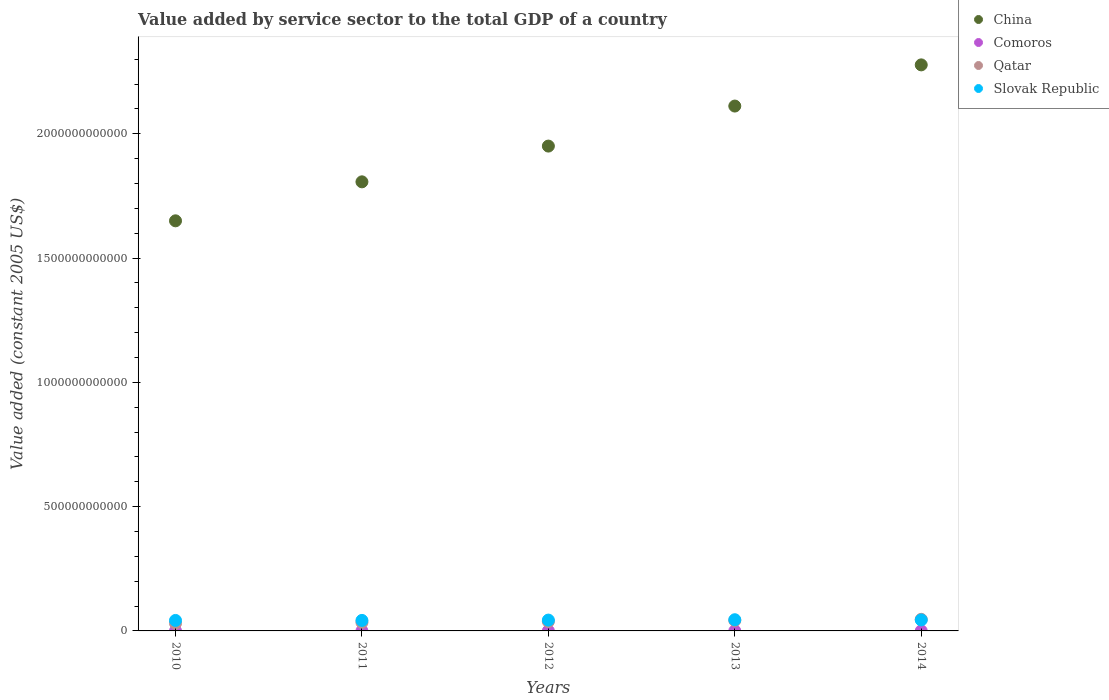What is the value added by service sector in Slovak Republic in 2014?
Offer a terse response. 4.41e+1. Across all years, what is the maximum value added by service sector in Qatar?
Provide a short and direct response. 4.66e+1. Across all years, what is the minimum value added by service sector in Slovak Republic?
Your answer should be very brief. 4.22e+1. In which year was the value added by service sector in Slovak Republic minimum?
Your answer should be compact. 2010. What is the total value added by service sector in Slovak Republic in the graph?
Your response must be concise. 2.17e+11. What is the difference between the value added by service sector in Slovak Republic in 2011 and that in 2014?
Make the answer very short. -1.86e+09. What is the difference between the value added by service sector in Qatar in 2014 and the value added by service sector in Comoros in 2010?
Your answer should be very brief. 4.64e+1. What is the average value added by service sector in Comoros per year?
Your answer should be very brief. 1.92e+08. In the year 2011, what is the difference between the value added by service sector in Slovak Republic and value added by service sector in Qatar?
Provide a short and direct response. 8.12e+09. In how many years, is the value added by service sector in Slovak Republic greater than 1600000000000 US$?
Your answer should be compact. 0. What is the ratio of the value added by service sector in Slovak Republic in 2010 to that in 2013?
Keep it short and to the point. 0.94. What is the difference between the highest and the second highest value added by service sector in Qatar?
Offer a very short reply. 4.80e+09. What is the difference between the highest and the lowest value added by service sector in Comoros?
Provide a short and direct response. 1.56e+07. In how many years, is the value added by service sector in Qatar greater than the average value added by service sector in Qatar taken over all years?
Make the answer very short. 2. Is it the case that in every year, the sum of the value added by service sector in Qatar and value added by service sector in China  is greater than the sum of value added by service sector in Comoros and value added by service sector in Slovak Republic?
Ensure brevity in your answer.  Yes. Is it the case that in every year, the sum of the value added by service sector in Slovak Republic and value added by service sector in Comoros  is greater than the value added by service sector in Qatar?
Provide a short and direct response. No. Is the value added by service sector in Comoros strictly greater than the value added by service sector in Slovak Republic over the years?
Keep it short and to the point. No. Is the value added by service sector in Qatar strictly less than the value added by service sector in China over the years?
Offer a terse response. Yes. What is the difference between two consecutive major ticks on the Y-axis?
Provide a short and direct response. 5.00e+11. How many legend labels are there?
Offer a very short reply. 4. What is the title of the graph?
Keep it short and to the point. Value added by service sector to the total GDP of a country. Does "Korea (Democratic)" appear as one of the legend labels in the graph?
Give a very brief answer. No. What is the label or title of the X-axis?
Give a very brief answer. Years. What is the label or title of the Y-axis?
Give a very brief answer. Value added (constant 2005 US$). What is the Value added (constant 2005 US$) in China in 2010?
Your answer should be compact. 1.65e+12. What is the Value added (constant 2005 US$) in Comoros in 2010?
Offer a very short reply. 1.86e+08. What is the Value added (constant 2005 US$) in Qatar in 2010?
Make the answer very short. 3.06e+1. What is the Value added (constant 2005 US$) in Slovak Republic in 2010?
Offer a terse response. 4.22e+1. What is the Value added (constant 2005 US$) of China in 2011?
Give a very brief answer. 1.81e+12. What is the Value added (constant 2005 US$) in Comoros in 2011?
Provide a succinct answer. 1.87e+08. What is the Value added (constant 2005 US$) of Qatar in 2011?
Ensure brevity in your answer.  3.41e+1. What is the Value added (constant 2005 US$) of Slovak Republic in 2011?
Keep it short and to the point. 4.23e+1. What is the Value added (constant 2005 US$) of China in 2012?
Make the answer very short. 1.95e+12. What is the Value added (constant 2005 US$) of Comoros in 2012?
Offer a very short reply. 1.90e+08. What is the Value added (constant 2005 US$) of Qatar in 2012?
Give a very brief answer. 3.76e+1. What is the Value added (constant 2005 US$) in Slovak Republic in 2012?
Give a very brief answer. 4.36e+1. What is the Value added (constant 2005 US$) of China in 2013?
Your response must be concise. 2.11e+12. What is the Value added (constant 2005 US$) in Comoros in 2013?
Your response must be concise. 1.96e+08. What is the Value added (constant 2005 US$) of Qatar in 2013?
Offer a very short reply. 4.18e+1. What is the Value added (constant 2005 US$) of Slovak Republic in 2013?
Provide a short and direct response. 4.51e+1. What is the Value added (constant 2005 US$) in China in 2014?
Keep it short and to the point. 2.28e+12. What is the Value added (constant 2005 US$) in Comoros in 2014?
Provide a succinct answer. 2.02e+08. What is the Value added (constant 2005 US$) of Qatar in 2014?
Offer a terse response. 4.66e+1. What is the Value added (constant 2005 US$) in Slovak Republic in 2014?
Provide a succinct answer. 4.41e+1. Across all years, what is the maximum Value added (constant 2005 US$) of China?
Offer a very short reply. 2.28e+12. Across all years, what is the maximum Value added (constant 2005 US$) of Comoros?
Your answer should be very brief. 2.02e+08. Across all years, what is the maximum Value added (constant 2005 US$) of Qatar?
Your response must be concise. 4.66e+1. Across all years, what is the maximum Value added (constant 2005 US$) in Slovak Republic?
Ensure brevity in your answer.  4.51e+1. Across all years, what is the minimum Value added (constant 2005 US$) in China?
Your answer should be compact. 1.65e+12. Across all years, what is the minimum Value added (constant 2005 US$) of Comoros?
Your response must be concise. 1.86e+08. Across all years, what is the minimum Value added (constant 2005 US$) in Qatar?
Your answer should be very brief. 3.06e+1. Across all years, what is the minimum Value added (constant 2005 US$) of Slovak Republic?
Provide a succinct answer. 4.22e+1. What is the total Value added (constant 2005 US$) of China in the graph?
Your response must be concise. 9.80e+12. What is the total Value added (constant 2005 US$) in Comoros in the graph?
Provide a short and direct response. 9.61e+08. What is the total Value added (constant 2005 US$) of Qatar in the graph?
Give a very brief answer. 1.91e+11. What is the total Value added (constant 2005 US$) of Slovak Republic in the graph?
Ensure brevity in your answer.  2.17e+11. What is the difference between the Value added (constant 2005 US$) in China in 2010 and that in 2011?
Ensure brevity in your answer.  -1.57e+11. What is the difference between the Value added (constant 2005 US$) of Comoros in 2010 and that in 2011?
Ensure brevity in your answer.  -1.22e+06. What is the difference between the Value added (constant 2005 US$) in Qatar in 2010 and that in 2011?
Your answer should be compact. -3.55e+09. What is the difference between the Value added (constant 2005 US$) of Slovak Republic in 2010 and that in 2011?
Keep it short and to the point. -1.08e+08. What is the difference between the Value added (constant 2005 US$) of China in 2010 and that in 2012?
Your answer should be compact. -3.01e+11. What is the difference between the Value added (constant 2005 US$) of Comoros in 2010 and that in 2012?
Make the answer very short. -4.23e+06. What is the difference between the Value added (constant 2005 US$) in Qatar in 2010 and that in 2012?
Ensure brevity in your answer.  -7.02e+09. What is the difference between the Value added (constant 2005 US$) in Slovak Republic in 2010 and that in 2012?
Give a very brief answer. -1.45e+09. What is the difference between the Value added (constant 2005 US$) of China in 2010 and that in 2013?
Keep it short and to the point. -4.62e+11. What is the difference between the Value added (constant 2005 US$) in Comoros in 2010 and that in 2013?
Your response must be concise. -9.68e+06. What is the difference between the Value added (constant 2005 US$) of Qatar in 2010 and that in 2013?
Your answer should be compact. -1.12e+1. What is the difference between the Value added (constant 2005 US$) in Slovak Republic in 2010 and that in 2013?
Make the answer very short. -2.90e+09. What is the difference between the Value added (constant 2005 US$) of China in 2010 and that in 2014?
Your answer should be compact. -6.27e+11. What is the difference between the Value added (constant 2005 US$) in Comoros in 2010 and that in 2014?
Your response must be concise. -1.56e+07. What is the difference between the Value added (constant 2005 US$) of Qatar in 2010 and that in 2014?
Your response must be concise. -1.60e+1. What is the difference between the Value added (constant 2005 US$) in Slovak Republic in 2010 and that in 2014?
Ensure brevity in your answer.  -1.97e+09. What is the difference between the Value added (constant 2005 US$) of China in 2011 and that in 2012?
Offer a terse response. -1.44e+11. What is the difference between the Value added (constant 2005 US$) in Comoros in 2011 and that in 2012?
Keep it short and to the point. -3.01e+06. What is the difference between the Value added (constant 2005 US$) of Qatar in 2011 and that in 2012?
Offer a very short reply. -3.47e+09. What is the difference between the Value added (constant 2005 US$) of Slovak Republic in 2011 and that in 2012?
Keep it short and to the point. -1.35e+09. What is the difference between the Value added (constant 2005 US$) of China in 2011 and that in 2013?
Your answer should be very brief. -3.05e+11. What is the difference between the Value added (constant 2005 US$) in Comoros in 2011 and that in 2013?
Ensure brevity in your answer.  -8.47e+06. What is the difference between the Value added (constant 2005 US$) of Qatar in 2011 and that in 2013?
Make the answer very short. -7.67e+09. What is the difference between the Value added (constant 2005 US$) of Slovak Republic in 2011 and that in 2013?
Your response must be concise. -2.79e+09. What is the difference between the Value added (constant 2005 US$) of China in 2011 and that in 2014?
Keep it short and to the point. -4.71e+11. What is the difference between the Value added (constant 2005 US$) of Comoros in 2011 and that in 2014?
Ensure brevity in your answer.  -1.44e+07. What is the difference between the Value added (constant 2005 US$) of Qatar in 2011 and that in 2014?
Offer a terse response. -1.25e+1. What is the difference between the Value added (constant 2005 US$) of Slovak Republic in 2011 and that in 2014?
Ensure brevity in your answer.  -1.86e+09. What is the difference between the Value added (constant 2005 US$) in China in 2012 and that in 2013?
Ensure brevity in your answer.  -1.61e+11. What is the difference between the Value added (constant 2005 US$) in Comoros in 2012 and that in 2013?
Offer a very short reply. -5.45e+06. What is the difference between the Value added (constant 2005 US$) of Qatar in 2012 and that in 2013?
Your answer should be compact. -4.20e+09. What is the difference between the Value added (constant 2005 US$) of Slovak Republic in 2012 and that in 2013?
Make the answer very short. -1.44e+09. What is the difference between the Value added (constant 2005 US$) in China in 2012 and that in 2014?
Your response must be concise. -3.27e+11. What is the difference between the Value added (constant 2005 US$) in Comoros in 2012 and that in 2014?
Your answer should be very brief. -1.14e+07. What is the difference between the Value added (constant 2005 US$) in Qatar in 2012 and that in 2014?
Give a very brief answer. -9.00e+09. What is the difference between the Value added (constant 2005 US$) in Slovak Republic in 2012 and that in 2014?
Keep it short and to the point. -5.15e+08. What is the difference between the Value added (constant 2005 US$) of China in 2013 and that in 2014?
Make the answer very short. -1.66e+11. What is the difference between the Value added (constant 2005 US$) of Comoros in 2013 and that in 2014?
Make the answer very short. -5.92e+06. What is the difference between the Value added (constant 2005 US$) of Qatar in 2013 and that in 2014?
Keep it short and to the point. -4.80e+09. What is the difference between the Value added (constant 2005 US$) of Slovak Republic in 2013 and that in 2014?
Your response must be concise. 9.28e+08. What is the difference between the Value added (constant 2005 US$) of China in 2010 and the Value added (constant 2005 US$) of Comoros in 2011?
Your answer should be compact. 1.65e+12. What is the difference between the Value added (constant 2005 US$) of China in 2010 and the Value added (constant 2005 US$) of Qatar in 2011?
Offer a very short reply. 1.62e+12. What is the difference between the Value added (constant 2005 US$) of China in 2010 and the Value added (constant 2005 US$) of Slovak Republic in 2011?
Your answer should be compact. 1.61e+12. What is the difference between the Value added (constant 2005 US$) in Comoros in 2010 and the Value added (constant 2005 US$) in Qatar in 2011?
Your response must be concise. -3.40e+1. What is the difference between the Value added (constant 2005 US$) of Comoros in 2010 and the Value added (constant 2005 US$) of Slovak Republic in 2011?
Provide a succinct answer. -4.21e+1. What is the difference between the Value added (constant 2005 US$) in Qatar in 2010 and the Value added (constant 2005 US$) in Slovak Republic in 2011?
Give a very brief answer. -1.17e+1. What is the difference between the Value added (constant 2005 US$) in China in 2010 and the Value added (constant 2005 US$) in Comoros in 2012?
Offer a very short reply. 1.65e+12. What is the difference between the Value added (constant 2005 US$) in China in 2010 and the Value added (constant 2005 US$) in Qatar in 2012?
Keep it short and to the point. 1.61e+12. What is the difference between the Value added (constant 2005 US$) in China in 2010 and the Value added (constant 2005 US$) in Slovak Republic in 2012?
Provide a succinct answer. 1.61e+12. What is the difference between the Value added (constant 2005 US$) in Comoros in 2010 and the Value added (constant 2005 US$) in Qatar in 2012?
Make the answer very short. -3.74e+1. What is the difference between the Value added (constant 2005 US$) in Comoros in 2010 and the Value added (constant 2005 US$) in Slovak Republic in 2012?
Keep it short and to the point. -4.34e+1. What is the difference between the Value added (constant 2005 US$) in Qatar in 2010 and the Value added (constant 2005 US$) in Slovak Republic in 2012?
Provide a short and direct response. -1.30e+1. What is the difference between the Value added (constant 2005 US$) in China in 2010 and the Value added (constant 2005 US$) in Comoros in 2013?
Offer a terse response. 1.65e+12. What is the difference between the Value added (constant 2005 US$) in China in 2010 and the Value added (constant 2005 US$) in Qatar in 2013?
Ensure brevity in your answer.  1.61e+12. What is the difference between the Value added (constant 2005 US$) in China in 2010 and the Value added (constant 2005 US$) in Slovak Republic in 2013?
Your answer should be compact. 1.60e+12. What is the difference between the Value added (constant 2005 US$) of Comoros in 2010 and the Value added (constant 2005 US$) of Qatar in 2013?
Ensure brevity in your answer.  -4.16e+1. What is the difference between the Value added (constant 2005 US$) in Comoros in 2010 and the Value added (constant 2005 US$) in Slovak Republic in 2013?
Provide a short and direct response. -4.49e+1. What is the difference between the Value added (constant 2005 US$) of Qatar in 2010 and the Value added (constant 2005 US$) of Slovak Republic in 2013?
Your answer should be very brief. -1.45e+1. What is the difference between the Value added (constant 2005 US$) of China in 2010 and the Value added (constant 2005 US$) of Comoros in 2014?
Offer a very short reply. 1.65e+12. What is the difference between the Value added (constant 2005 US$) of China in 2010 and the Value added (constant 2005 US$) of Qatar in 2014?
Provide a short and direct response. 1.60e+12. What is the difference between the Value added (constant 2005 US$) of China in 2010 and the Value added (constant 2005 US$) of Slovak Republic in 2014?
Provide a succinct answer. 1.61e+12. What is the difference between the Value added (constant 2005 US$) of Comoros in 2010 and the Value added (constant 2005 US$) of Qatar in 2014?
Ensure brevity in your answer.  -4.64e+1. What is the difference between the Value added (constant 2005 US$) of Comoros in 2010 and the Value added (constant 2005 US$) of Slovak Republic in 2014?
Provide a short and direct response. -4.39e+1. What is the difference between the Value added (constant 2005 US$) in Qatar in 2010 and the Value added (constant 2005 US$) in Slovak Republic in 2014?
Your response must be concise. -1.35e+1. What is the difference between the Value added (constant 2005 US$) in China in 2011 and the Value added (constant 2005 US$) in Comoros in 2012?
Offer a terse response. 1.81e+12. What is the difference between the Value added (constant 2005 US$) of China in 2011 and the Value added (constant 2005 US$) of Qatar in 2012?
Your response must be concise. 1.77e+12. What is the difference between the Value added (constant 2005 US$) of China in 2011 and the Value added (constant 2005 US$) of Slovak Republic in 2012?
Offer a very short reply. 1.76e+12. What is the difference between the Value added (constant 2005 US$) of Comoros in 2011 and the Value added (constant 2005 US$) of Qatar in 2012?
Your answer should be very brief. -3.74e+1. What is the difference between the Value added (constant 2005 US$) in Comoros in 2011 and the Value added (constant 2005 US$) in Slovak Republic in 2012?
Your answer should be compact. -4.34e+1. What is the difference between the Value added (constant 2005 US$) of Qatar in 2011 and the Value added (constant 2005 US$) of Slovak Republic in 2012?
Make the answer very short. -9.47e+09. What is the difference between the Value added (constant 2005 US$) of China in 2011 and the Value added (constant 2005 US$) of Comoros in 2013?
Your answer should be compact. 1.81e+12. What is the difference between the Value added (constant 2005 US$) in China in 2011 and the Value added (constant 2005 US$) in Qatar in 2013?
Offer a very short reply. 1.76e+12. What is the difference between the Value added (constant 2005 US$) of China in 2011 and the Value added (constant 2005 US$) of Slovak Republic in 2013?
Your answer should be very brief. 1.76e+12. What is the difference between the Value added (constant 2005 US$) in Comoros in 2011 and the Value added (constant 2005 US$) in Qatar in 2013?
Your answer should be compact. -4.16e+1. What is the difference between the Value added (constant 2005 US$) of Comoros in 2011 and the Value added (constant 2005 US$) of Slovak Republic in 2013?
Your response must be concise. -4.49e+1. What is the difference between the Value added (constant 2005 US$) of Qatar in 2011 and the Value added (constant 2005 US$) of Slovak Republic in 2013?
Ensure brevity in your answer.  -1.09e+1. What is the difference between the Value added (constant 2005 US$) in China in 2011 and the Value added (constant 2005 US$) in Comoros in 2014?
Offer a very short reply. 1.81e+12. What is the difference between the Value added (constant 2005 US$) of China in 2011 and the Value added (constant 2005 US$) of Qatar in 2014?
Ensure brevity in your answer.  1.76e+12. What is the difference between the Value added (constant 2005 US$) of China in 2011 and the Value added (constant 2005 US$) of Slovak Republic in 2014?
Make the answer very short. 1.76e+12. What is the difference between the Value added (constant 2005 US$) in Comoros in 2011 and the Value added (constant 2005 US$) in Qatar in 2014?
Give a very brief answer. -4.64e+1. What is the difference between the Value added (constant 2005 US$) in Comoros in 2011 and the Value added (constant 2005 US$) in Slovak Republic in 2014?
Give a very brief answer. -4.39e+1. What is the difference between the Value added (constant 2005 US$) in Qatar in 2011 and the Value added (constant 2005 US$) in Slovak Republic in 2014?
Offer a terse response. -9.98e+09. What is the difference between the Value added (constant 2005 US$) in China in 2012 and the Value added (constant 2005 US$) in Comoros in 2013?
Make the answer very short. 1.95e+12. What is the difference between the Value added (constant 2005 US$) of China in 2012 and the Value added (constant 2005 US$) of Qatar in 2013?
Ensure brevity in your answer.  1.91e+12. What is the difference between the Value added (constant 2005 US$) in China in 2012 and the Value added (constant 2005 US$) in Slovak Republic in 2013?
Ensure brevity in your answer.  1.91e+12. What is the difference between the Value added (constant 2005 US$) of Comoros in 2012 and the Value added (constant 2005 US$) of Qatar in 2013?
Make the answer very short. -4.16e+1. What is the difference between the Value added (constant 2005 US$) of Comoros in 2012 and the Value added (constant 2005 US$) of Slovak Republic in 2013?
Ensure brevity in your answer.  -4.49e+1. What is the difference between the Value added (constant 2005 US$) of Qatar in 2012 and the Value added (constant 2005 US$) of Slovak Republic in 2013?
Make the answer very short. -7.45e+09. What is the difference between the Value added (constant 2005 US$) in China in 2012 and the Value added (constant 2005 US$) in Comoros in 2014?
Ensure brevity in your answer.  1.95e+12. What is the difference between the Value added (constant 2005 US$) in China in 2012 and the Value added (constant 2005 US$) in Qatar in 2014?
Offer a terse response. 1.90e+12. What is the difference between the Value added (constant 2005 US$) in China in 2012 and the Value added (constant 2005 US$) in Slovak Republic in 2014?
Your response must be concise. 1.91e+12. What is the difference between the Value added (constant 2005 US$) in Comoros in 2012 and the Value added (constant 2005 US$) in Qatar in 2014?
Give a very brief answer. -4.64e+1. What is the difference between the Value added (constant 2005 US$) in Comoros in 2012 and the Value added (constant 2005 US$) in Slovak Republic in 2014?
Offer a very short reply. -4.39e+1. What is the difference between the Value added (constant 2005 US$) of Qatar in 2012 and the Value added (constant 2005 US$) of Slovak Republic in 2014?
Your response must be concise. -6.52e+09. What is the difference between the Value added (constant 2005 US$) in China in 2013 and the Value added (constant 2005 US$) in Comoros in 2014?
Your response must be concise. 2.11e+12. What is the difference between the Value added (constant 2005 US$) in China in 2013 and the Value added (constant 2005 US$) in Qatar in 2014?
Your answer should be compact. 2.06e+12. What is the difference between the Value added (constant 2005 US$) of China in 2013 and the Value added (constant 2005 US$) of Slovak Republic in 2014?
Keep it short and to the point. 2.07e+12. What is the difference between the Value added (constant 2005 US$) in Comoros in 2013 and the Value added (constant 2005 US$) in Qatar in 2014?
Your answer should be compact. -4.64e+1. What is the difference between the Value added (constant 2005 US$) of Comoros in 2013 and the Value added (constant 2005 US$) of Slovak Republic in 2014?
Offer a very short reply. -4.39e+1. What is the difference between the Value added (constant 2005 US$) in Qatar in 2013 and the Value added (constant 2005 US$) in Slovak Republic in 2014?
Your answer should be very brief. -2.32e+09. What is the average Value added (constant 2005 US$) in China per year?
Offer a terse response. 1.96e+12. What is the average Value added (constant 2005 US$) in Comoros per year?
Ensure brevity in your answer.  1.92e+08. What is the average Value added (constant 2005 US$) of Qatar per year?
Ensure brevity in your answer.  3.82e+1. What is the average Value added (constant 2005 US$) of Slovak Republic per year?
Offer a very short reply. 4.34e+1. In the year 2010, what is the difference between the Value added (constant 2005 US$) of China and Value added (constant 2005 US$) of Comoros?
Provide a short and direct response. 1.65e+12. In the year 2010, what is the difference between the Value added (constant 2005 US$) in China and Value added (constant 2005 US$) in Qatar?
Make the answer very short. 1.62e+12. In the year 2010, what is the difference between the Value added (constant 2005 US$) in China and Value added (constant 2005 US$) in Slovak Republic?
Your response must be concise. 1.61e+12. In the year 2010, what is the difference between the Value added (constant 2005 US$) of Comoros and Value added (constant 2005 US$) of Qatar?
Ensure brevity in your answer.  -3.04e+1. In the year 2010, what is the difference between the Value added (constant 2005 US$) in Comoros and Value added (constant 2005 US$) in Slovak Republic?
Make the answer very short. -4.20e+1. In the year 2010, what is the difference between the Value added (constant 2005 US$) in Qatar and Value added (constant 2005 US$) in Slovak Republic?
Offer a very short reply. -1.16e+1. In the year 2011, what is the difference between the Value added (constant 2005 US$) of China and Value added (constant 2005 US$) of Comoros?
Offer a very short reply. 1.81e+12. In the year 2011, what is the difference between the Value added (constant 2005 US$) of China and Value added (constant 2005 US$) of Qatar?
Your answer should be very brief. 1.77e+12. In the year 2011, what is the difference between the Value added (constant 2005 US$) in China and Value added (constant 2005 US$) in Slovak Republic?
Provide a succinct answer. 1.76e+12. In the year 2011, what is the difference between the Value added (constant 2005 US$) of Comoros and Value added (constant 2005 US$) of Qatar?
Provide a short and direct response. -3.40e+1. In the year 2011, what is the difference between the Value added (constant 2005 US$) of Comoros and Value added (constant 2005 US$) of Slovak Republic?
Provide a short and direct response. -4.21e+1. In the year 2011, what is the difference between the Value added (constant 2005 US$) of Qatar and Value added (constant 2005 US$) of Slovak Republic?
Offer a very short reply. -8.12e+09. In the year 2012, what is the difference between the Value added (constant 2005 US$) of China and Value added (constant 2005 US$) of Comoros?
Give a very brief answer. 1.95e+12. In the year 2012, what is the difference between the Value added (constant 2005 US$) of China and Value added (constant 2005 US$) of Qatar?
Your answer should be very brief. 1.91e+12. In the year 2012, what is the difference between the Value added (constant 2005 US$) of China and Value added (constant 2005 US$) of Slovak Republic?
Give a very brief answer. 1.91e+12. In the year 2012, what is the difference between the Value added (constant 2005 US$) of Comoros and Value added (constant 2005 US$) of Qatar?
Ensure brevity in your answer.  -3.74e+1. In the year 2012, what is the difference between the Value added (constant 2005 US$) in Comoros and Value added (constant 2005 US$) in Slovak Republic?
Keep it short and to the point. -4.34e+1. In the year 2012, what is the difference between the Value added (constant 2005 US$) of Qatar and Value added (constant 2005 US$) of Slovak Republic?
Make the answer very short. -6.00e+09. In the year 2013, what is the difference between the Value added (constant 2005 US$) of China and Value added (constant 2005 US$) of Comoros?
Your response must be concise. 2.11e+12. In the year 2013, what is the difference between the Value added (constant 2005 US$) of China and Value added (constant 2005 US$) of Qatar?
Your answer should be compact. 2.07e+12. In the year 2013, what is the difference between the Value added (constant 2005 US$) in China and Value added (constant 2005 US$) in Slovak Republic?
Your answer should be very brief. 2.07e+12. In the year 2013, what is the difference between the Value added (constant 2005 US$) of Comoros and Value added (constant 2005 US$) of Qatar?
Ensure brevity in your answer.  -4.16e+1. In the year 2013, what is the difference between the Value added (constant 2005 US$) of Comoros and Value added (constant 2005 US$) of Slovak Republic?
Keep it short and to the point. -4.49e+1. In the year 2013, what is the difference between the Value added (constant 2005 US$) of Qatar and Value added (constant 2005 US$) of Slovak Republic?
Ensure brevity in your answer.  -3.25e+09. In the year 2014, what is the difference between the Value added (constant 2005 US$) of China and Value added (constant 2005 US$) of Comoros?
Give a very brief answer. 2.28e+12. In the year 2014, what is the difference between the Value added (constant 2005 US$) of China and Value added (constant 2005 US$) of Qatar?
Give a very brief answer. 2.23e+12. In the year 2014, what is the difference between the Value added (constant 2005 US$) in China and Value added (constant 2005 US$) in Slovak Republic?
Provide a short and direct response. 2.23e+12. In the year 2014, what is the difference between the Value added (constant 2005 US$) in Comoros and Value added (constant 2005 US$) in Qatar?
Your response must be concise. -4.64e+1. In the year 2014, what is the difference between the Value added (constant 2005 US$) in Comoros and Value added (constant 2005 US$) in Slovak Republic?
Your response must be concise. -4.39e+1. In the year 2014, what is the difference between the Value added (constant 2005 US$) of Qatar and Value added (constant 2005 US$) of Slovak Republic?
Keep it short and to the point. 2.48e+09. What is the ratio of the Value added (constant 2005 US$) in China in 2010 to that in 2011?
Provide a succinct answer. 0.91. What is the ratio of the Value added (constant 2005 US$) in Comoros in 2010 to that in 2011?
Ensure brevity in your answer.  0.99. What is the ratio of the Value added (constant 2005 US$) in Qatar in 2010 to that in 2011?
Keep it short and to the point. 0.9. What is the ratio of the Value added (constant 2005 US$) in Slovak Republic in 2010 to that in 2011?
Your answer should be very brief. 1. What is the ratio of the Value added (constant 2005 US$) in China in 2010 to that in 2012?
Your answer should be very brief. 0.85. What is the ratio of the Value added (constant 2005 US$) in Comoros in 2010 to that in 2012?
Provide a succinct answer. 0.98. What is the ratio of the Value added (constant 2005 US$) in Qatar in 2010 to that in 2012?
Offer a very short reply. 0.81. What is the ratio of the Value added (constant 2005 US$) of Slovak Republic in 2010 to that in 2012?
Give a very brief answer. 0.97. What is the ratio of the Value added (constant 2005 US$) in China in 2010 to that in 2013?
Provide a succinct answer. 0.78. What is the ratio of the Value added (constant 2005 US$) in Comoros in 2010 to that in 2013?
Give a very brief answer. 0.95. What is the ratio of the Value added (constant 2005 US$) of Qatar in 2010 to that in 2013?
Keep it short and to the point. 0.73. What is the ratio of the Value added (constant 2005 US$) of Slovak Republic in 2010 to that in 2013?
Your answer should be compact. 0.94. What is the ratio of the Value added (constant 2005 US$) in China in 2010 to that in 2014?
Offer a terse response. 0.72. What is the ratio of the Value added (constant 2005 US$) of Comoros in 2010 to that in 2014?
Your response must be concise. 0.92. What is the ratio of the Value added (constant 2005 US$) in Qatar in 2010 to that in 2014?
Keep it short and to the point. 0.66. What is the ratio of the Value added (constant 2005 US$) in Slovak Republic in 2010 to that in 2014?
Make the answer very short. 0.96. What is the ratio of the Value added (constant 2005 US$) of China in 2011 to that in 2012?
Your response must be concise. 0.93. What is the ratio of the Value added (constant 2005 US$) in Comoros in 2011 to that in 2012?
Ensure brevity in your answer.  0.98. What is the ratio of the Value added (constant 2005 US$) in Qatar in 2011 to that in 2012?
Your answer should be very brief. 0.91. What is the ratio of the Value added (constant 2005 US$) in Slovak Republic in 2011 to that in 2012?
Offer a terse response. 0.97. What is the ratio of the Value added (constant 2005 US$) in China in 2011 to that in 2013?
Offer a terse response. 0.86. What is the ratio of the Value added (constant 2005 US$) in Comoros in 2011 to that in 2013?
Ensure brevity in your answer.  0.96. What is the ratio of the Value added (constant 2005 US$) of Qatar in 2011 to that in 2013?
Offer a very short reply. 0.82. What is the ratio of the Value added (constant 2005 US$) in Slovak Republic in 2011 to that in 2013?
Offer a very short reply. 0.94. What is the ratio of the Value added (constant 2005 US$) of China in 2011 to that in 2014?
Provide a short and direct response. 0.79. What is the ratio of the Value added (constant 2005 US$) in Comoros in 2011 to that in 2014?
Your response must be concise. 0.93. What is the ratio of the Value added (constant 2005 US$) of Qatar in 2011 to that in 2014?
Offer a terse response. 0.73. What is the ratio of the Value added (constant 2005 US$) of Slovak Republic in 2011 to that in 2014?
Offer a very short reply. 0.96. What is the ratio of the Value added (constant 2005 US$) in China in 2012 to that in 2013?
Give a very brief answer. 0.92. What is the ratio of the Value added (constant 2005 US$) in Comoros in 2012 to that in 2013?
Your response must be concise. 0.97. What is the ratio of the Value added (constant 2005 US$) of Qatar in 2012 to that in 2013?
Make the answer very short. 0.9. What is the ratio of the Value added (constant 2005 US$) of China in 2012 to that in 2014?
Provide a short and direct response. 0.86. What is the ratio of the Value added (constant 2005 US$) in Comoros in 2012 to that in 2014?
Offer a terse response. 0.94. What is the ratio of the Value added (constant 2005 US$) of Qatar in 2012 to that in 2014?
Your answer should be compact. 0.81. What is the ratio of the Value added (constant 2005 US$) in Slovak Republic in 2012 to that in 2014?
Offer a very short reply. 0.99. What is the ratio of the Value added (constant 2005 US$) of China in 2013 to that in 2014?
Provide a short and direct response. 0.93. What is the ratio of the Value added (constant 2005 US$) of Comoros in 2013 to that in 2014?
Ensure brevity in your answer.  0.97. What is the ratio of the Value added (constant 2005 US$) in Qatar in 2013 to that in 2014?
Give a very brief answer. 0.9. What is the ratio of the Value added (constant 2005 US$) of Slovak Republic in 2013 to that in 2014?
Your answer should be very brief. 1.02. What is the difference between the highest and the second highest Value added (constant 2005 US$) in China?
Provide a short and direct response. 1.66e+11. What is the difference between the highest and the second highest Value added (constant 2005 US$) of Comoros?
Offer a terse response. 5.92e+06. What is the difference between the highest and the second highest Value added (constant 2005 US$) in Qatar?
Offer a very short reply. 4.80e+09. What is the difference between the highest and the second highest Value added (constant 2005 US$) of Slovak Republic?
Make the answer very short. 9.28e+08. What is the difference between the highest and the lowest Value added (constant 2005 US$) of China?
Provide a short and direct response. 6.27e+11. What is the difference between the highest and the lowest Value added (constant 2005 US$) of Comoros?
Make the answer very short. 1.56e+07. What is the difference between the highest and the lowest Value added (constant 2005 US$) of Qatar?
Your answer should be very brief. 1.60e+1. What is the difference between the highest and the lowest Value added (constant 2005 US$) of Slovak Republic?
Ensure brevity in your answer.  2.90e+09. 